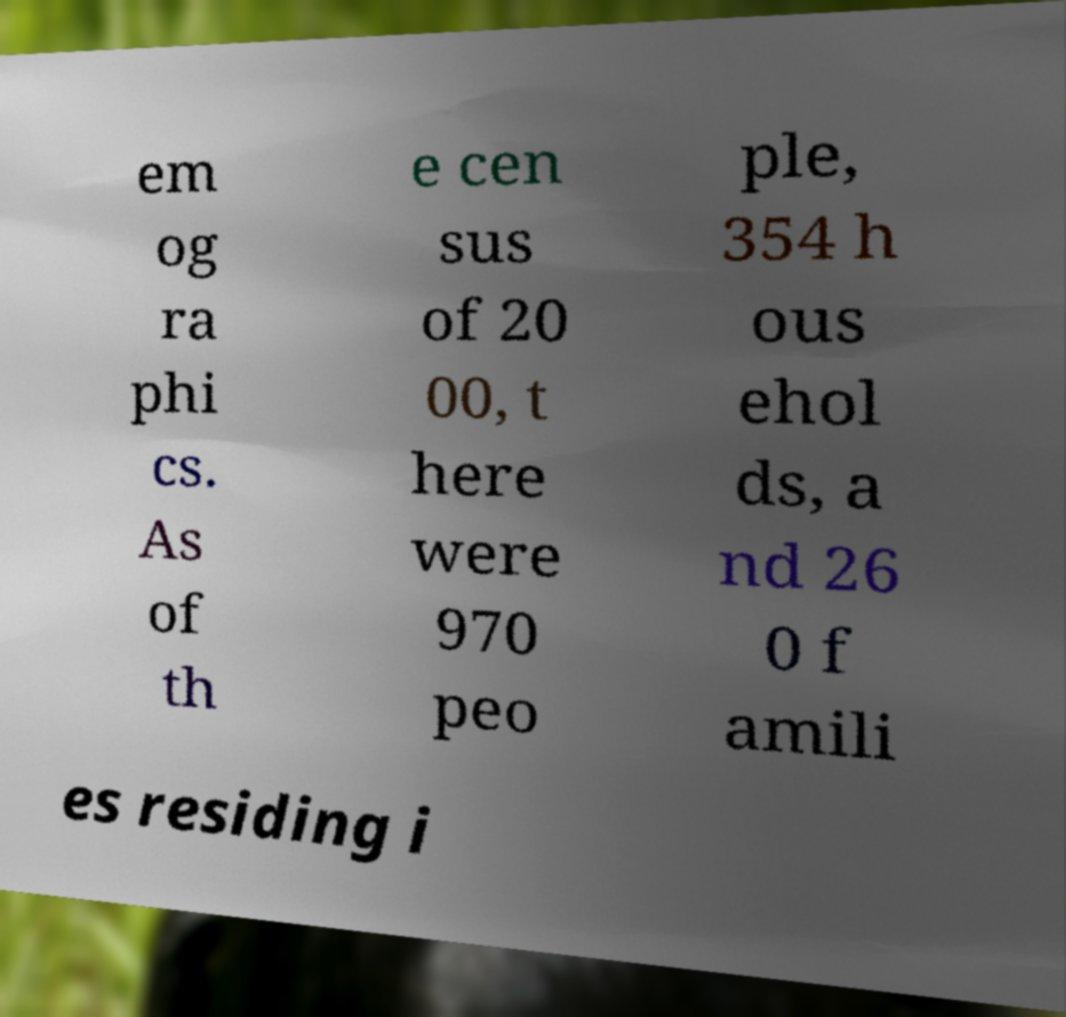There's text embedded in this image that I need extracted. Can you transcribe it verbatim? em og ra phi cs. As of th e cen sus of 20 00, t here were 970 peo ple, 354 h ous ehol ds, a nd 26 0 f amili es residing i 